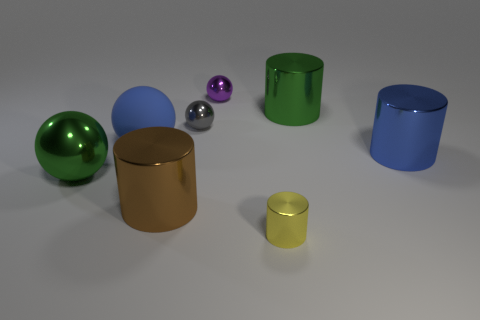Is there anything else that is made of the same material as the blue ball?
Make the answer very short. No. The metallic object that is the same color as the large matte ball is what shape?
Offer a very short reply. Cylinder. The blue rubber thing that is the same size as the brown cylinder is what shape?
Offer a very short reply. Sphere. There is a small gray object; are there any blue shiny things in front of it?
Provide a succinct answer. Yes. Is there another brown metallic object of the same shape as the big brown thing?
Offer a terse response. No. There is a big green thing left of the brown cylinder; is it the same shape as the small shiny thing that is behind the green metal cylinder?
Your answer should be very brief. Yes. Is there a blue cylinder that has the same size as the brown metallic cylinder?
Your answer should be very brief. Yes. Are there the same number of small gray balls on the left side of the brown shiny thing and large blue things left of the green cylinder?
Make the answer very short. No. Is the ball left of the big matte thing made of the same material as the cylinder behind the large blue shiny cylinder?
Give a very brief answer. Yes. What is the material of the large blue sphere?
Provide a succinct answer. Rubber. 